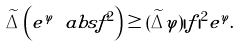<formula> <loc_0><loc_0><loc_500><loc_500>\widetilde { \Delta } \left ( e ^ { \varphi } \ a b s { f } ^ { 2 } \right ) \geq ( \widetilde { \Delta } \varphi ) | f | ^ { 2 } e ^ { \varphi } .</formula> 